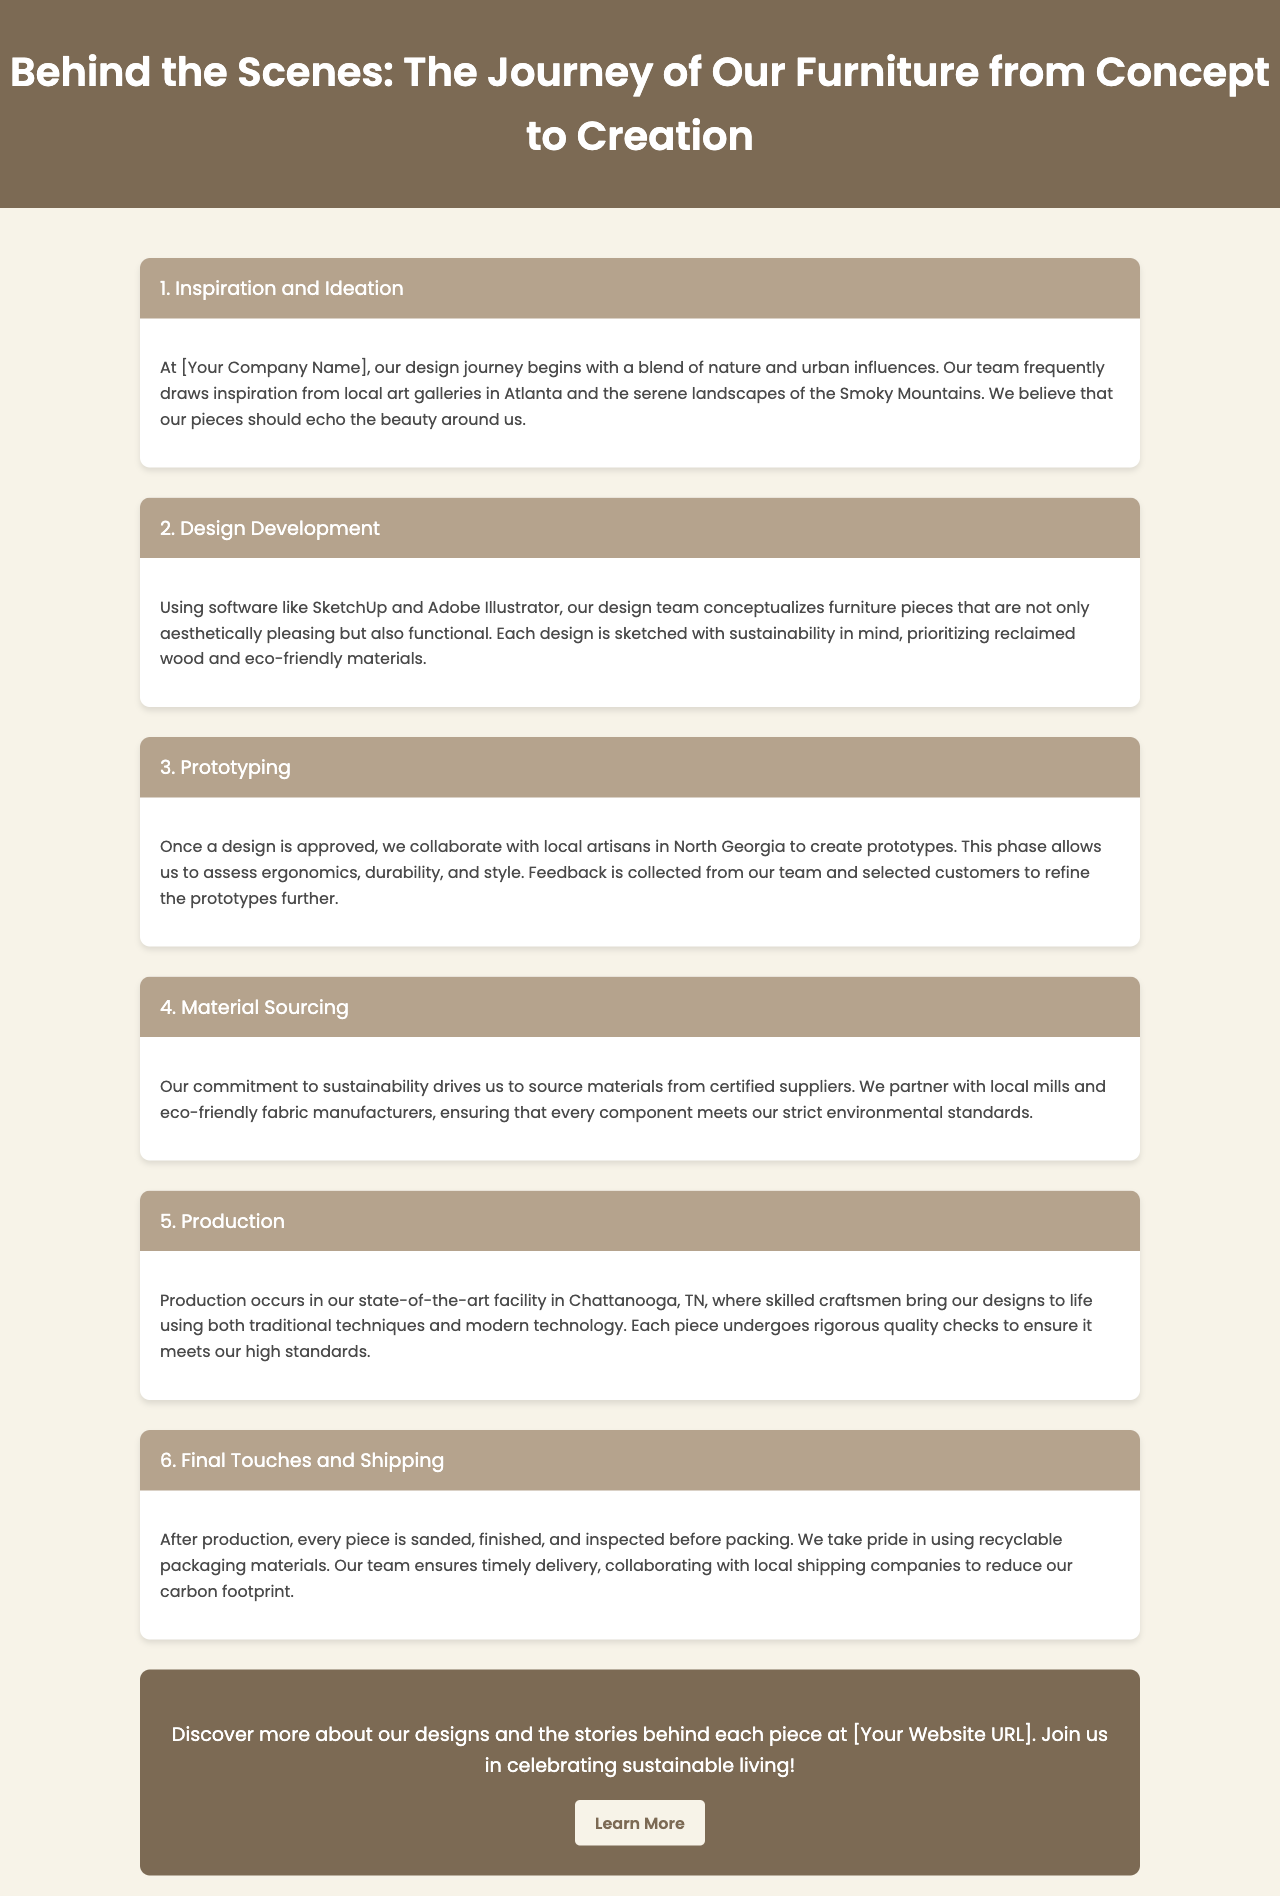What is the primary source of inspiration for the furniture designs? The primary sources of inspiration for the furniture designs are nature and urban influences, particularly local art galleries in Atlanta and the Smoky Mountains.
Answer: nature and urban influences Which software does the design team use for conceptualizing furniture? The design team uses software like SketchUp and Adobe Illustrator for conceptualizing furniture pieces.
Answer: SketchUp and Adobe Illustrator Where is the production facility located? The production facility is located in Chattanooga, TN, where skilled craftsmen bring the designs to life.
Answer: Chattanooga, TN What is prioritized in the design development phase? In the design development phase, sustainability is prioritized by using reclaimed wood and eco-friendly materials.
Answer: sustainability How does the company ensure the quality of its furniture? The company ensures the quality by subjecting each piece to rigorous quality checks during production.
Answer: rigorous quality checks What type of artisans does the company collaborate with to create prototypes? The company collaborates with local artisans in North Georgia to create prototypes.
Answer: local artisans in North Georgia What is the significance of the final inspection before shipping? The final inspection ensures that every piece is sanded, finished, and meets the quality standards before packing.
Answer: quality standards Which materials does the company use for packaging? The company uses recyclable packaging materials for shipping their furniture.
Answer: recyclable packaging materials 